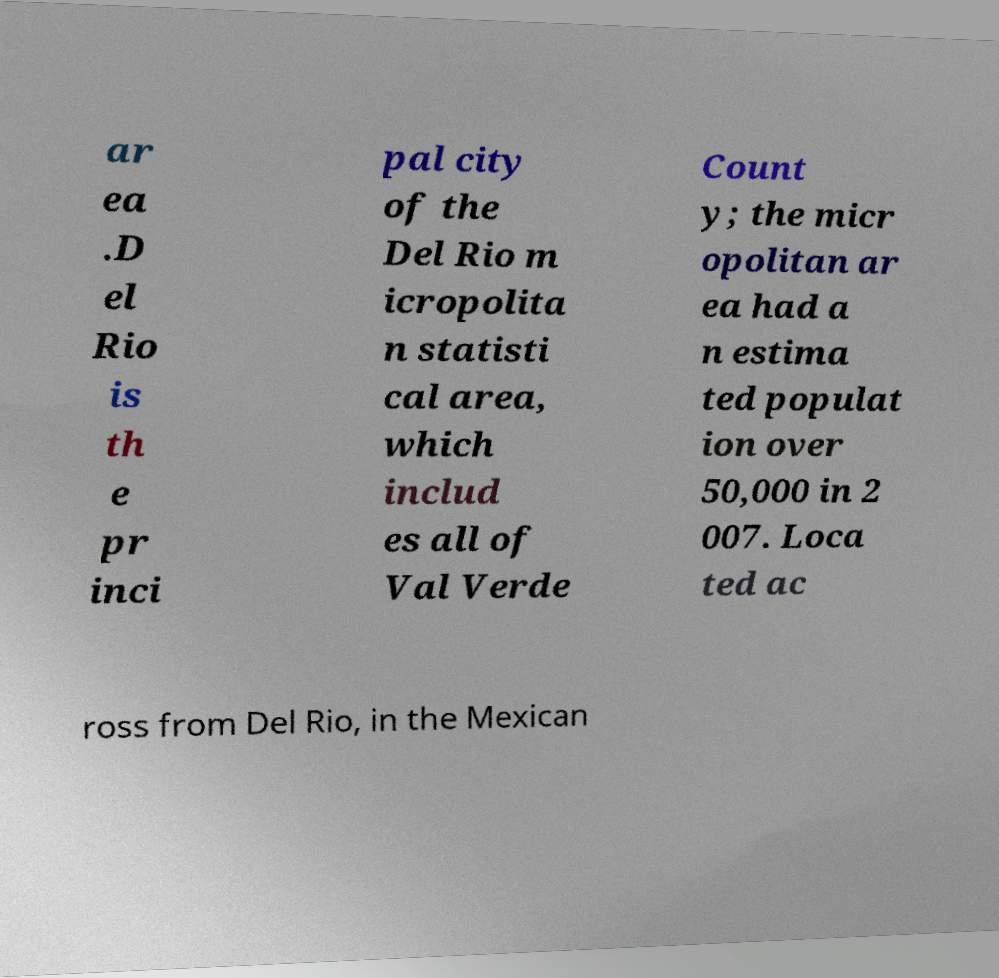There's text embedded in this image that I need extracted. Can you transcribe it verbatim? ar ea .D el Rio is th e pr inci pal city of the Del Rio m icropolita n statisti cal area, which includ es all of Val Verde Count y; the micr opolitan ar ea had a n estima ted populat ion over 50,000 in 2 007. Loca ted ac ross from Del Rio, in the Mexican 